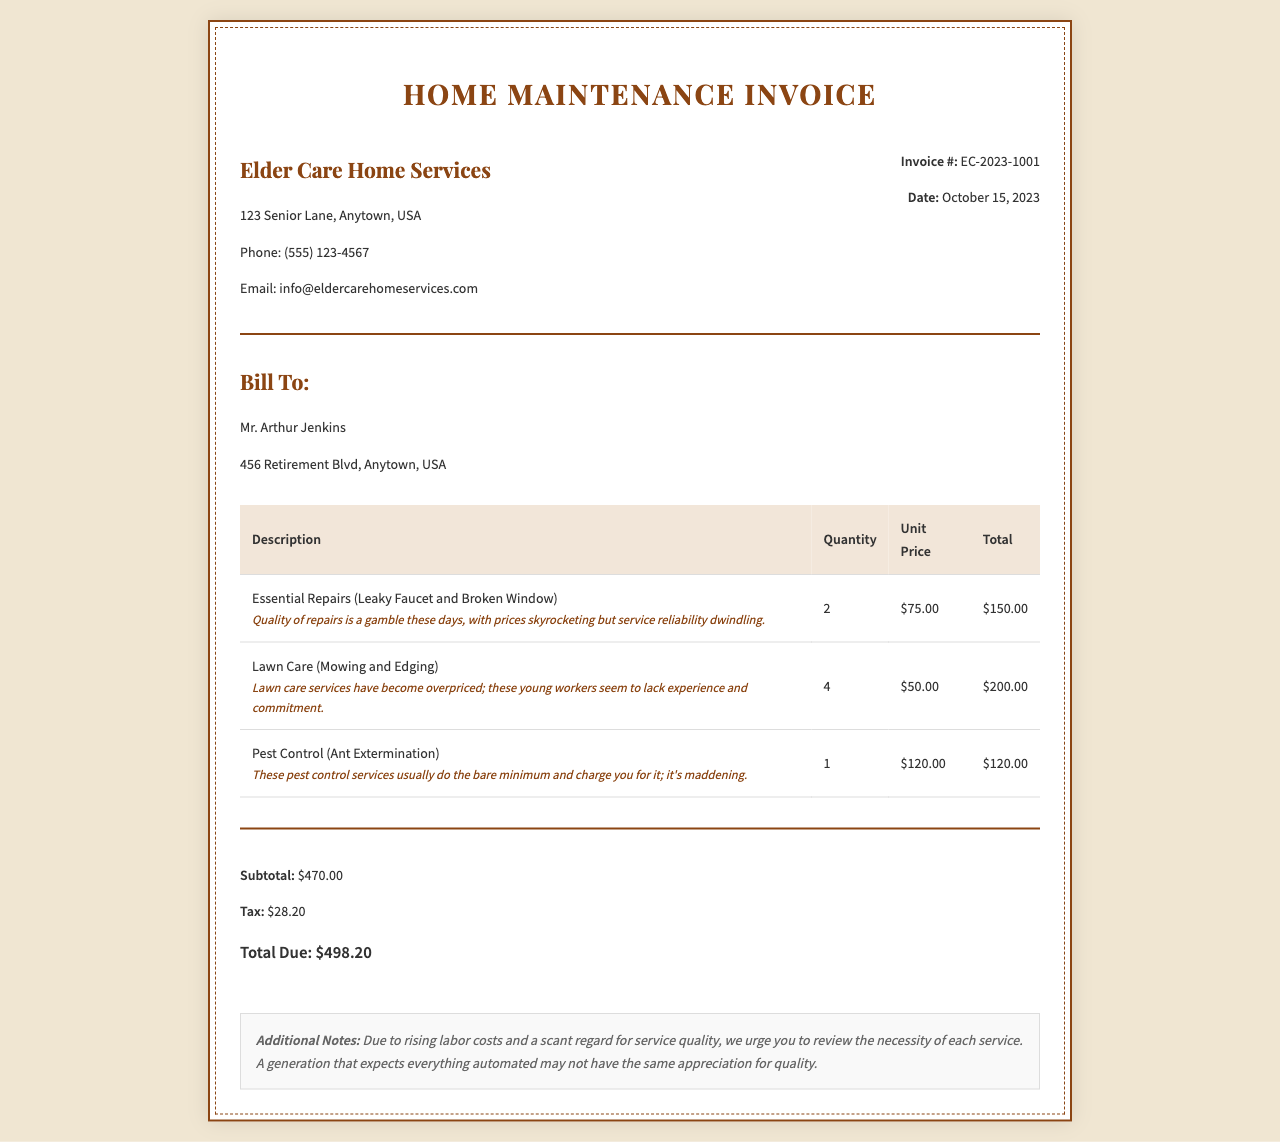What is the invoice number? The invoice number is listed in the document as a unique identifier for this receipt, which is EC-2023-1001.
Answer: EC-2023-1001 What is the date of the invoice? The date of the invoice is the day it was created, which is stated as October 15, 2023.
Answer: October 15, 2023 Who is the invoice billed to? The name of the person to whom the invoice is billed is clearly mentioned in the document as Mr. Arthur Jenkins.
Answer: Mr. Arthur Jenkins What is the unit price for pest control? The unit price for pest control services is provided in the table as a specified amount for this service, which is $120.00.
Answer: $120.00 What is the total due amount? The total due is summarized at the end of the invoice, which represents the complete expense owed by the customer, totaling $498.20.
Answer: $498.20 How many essential repairs were charged? The quantity of essential repairs is indicated in the table, showing the count of repairs conducted, which is 2.
Answer: 2 What concerns are expressed about lawn care services? The concerns regarding lawn care services relate to pricing and the perceived lack of experience among service providers, which is mentioned in the description.
Answer: Overpriced; lack of experience What is the subtotal before tax? The subtotal amount, which summarizes the costs prior to tax addition, is noted in the summary section of the document as $470.00.
Answer: $470.00 What type of services are included in the invoice? The types of services listed in the invoice encompass essential repairs, lawn care, and pest control, as detailed in the table.
Answer: Essential Repairs, Lawn Care, Pest Control 